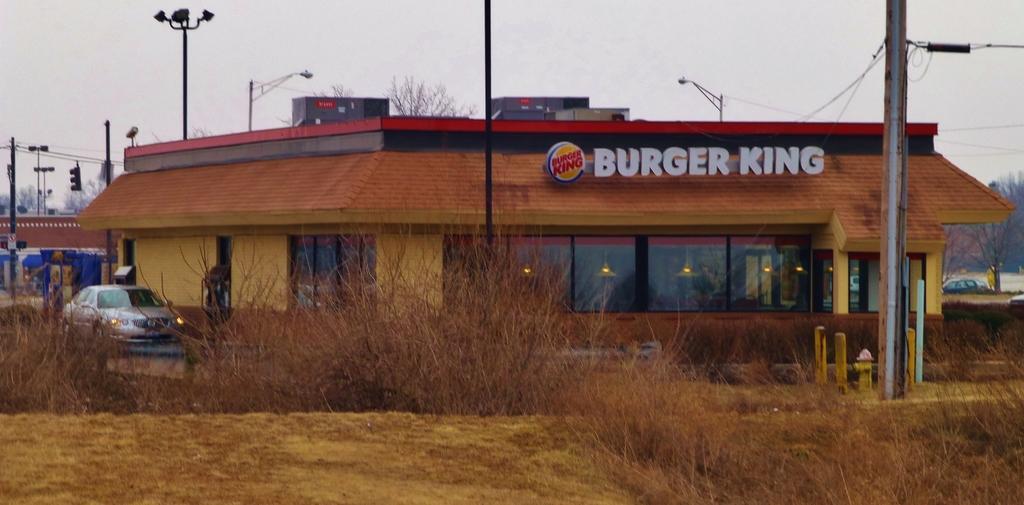Could you give a brief overview of what you see in this image? In this image we can see building with windows, sign board with text and some poles. In the foreground of the image we can see some some vehicles parked on the ground, some plants and fire hose. In the left side of the image we can see traffic lights and some trees. At the top of the image we can see the sky. 